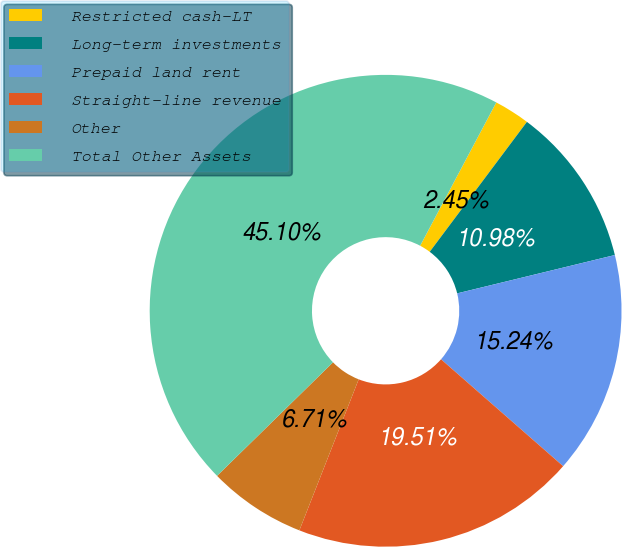Convert chart. <chart><loc_0><loc_0><loc_500><loc_500><pie_chart><fcel>Restricted cash-LT<fcel>Long-term investments<fcel>Prepaid land rent<fcel>Straight-line revenue<fcel>Other<fcel>Total Other Assets<nl><fcel>2.45%<fcel>10.98%<fcel>15.24%<fcel>19.51%<fcel>6.71%<fcel>45.1%<nl></chart> 